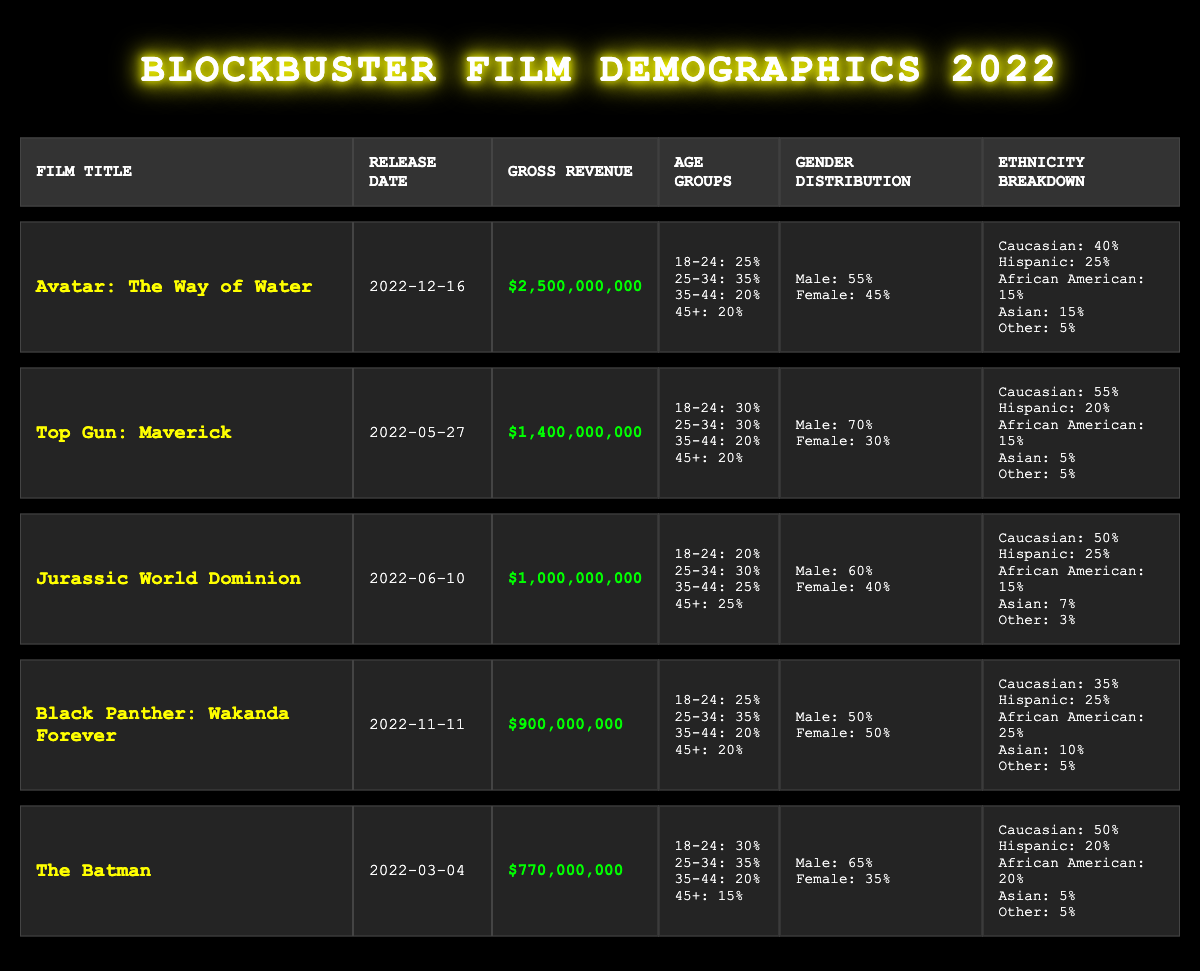What is the gross revenue of "Avatar: The Way of Water"? The gross revenue for "Avatar: The Way of Water" can be found in the table under the "Gross Revenue" column, which shows $2,500,000,000.
Answer: $2,500,000,000 What percentage of viewers for "Top Gun: Maverick" are male? The table states that the gender distribution for "Top Gun: Maverick" lists males at 70%.
Answer: 70% What is the average age percentage for viewers aged 35-44 across all films? Adding the percentages for age group 35-44: "Avatar: The Way of Water" (20%), "Top Gun: Maverick" (20%), "Jurassic World Dominion" (25%), "Black Panther: Wakanda Forever" (20%), "The Batman" (20%) gives us a total of 105%. There are 5 films, so the average is 105%/5 = 21%.
Answer: 21% Do more females or males watch "Black Panther: Wakanda Forever"? For "Black Panther: Wakanda Forever," the gender distribution shows males at 50% and females at 50%, indicating that they are equal.
Answer: No, they are equal (50% each) If you combine the gross revenues of "The Batman" and "Black Panther: Wakanda Forever," what total do you get? The gross revenue for "The Batman" is $770,000,000 and for "Black Panther: Wakanda Forever" it is $900,000,000. Adding these together $770,000,000 + $900,000,000 = $1,670,000,000.
Answer: $1,670,000,000 Is the percentage of Asian viewers for "Jurassic World Dominion" more than that of "The Batman"? "Jurassic World Dominion" has 7% Asian viewers and "The Batman" has 5%. Since 7% is greater than 5%, the answer is yes.
Answer: Yes How many films have a gender distribution where males make up 60% or more? Reviewing the gender distribution: "Top Gun: Maverick" (70%), "Jurassic World Dominion" (60%), "The Batman" (65%) meet the criteria. This totals to 3 films.
Answer: 3 